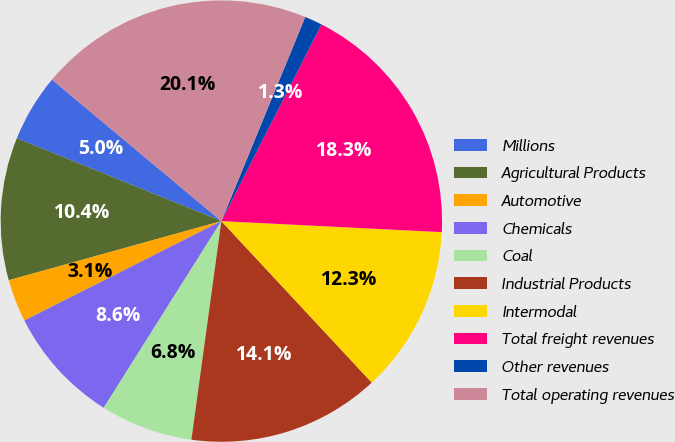<chart> <loc_0><loc_0><loc_500><loc_500><pie_chart><fcel>Millions<fcel>Agricultural Products<fcel>Automotive<fcel>Chemicals<fcel>Coal<fcel>Industrial Products<fcel>Intermodal<fcel>Total freight revenues<fcel>Other revenues<fcel>Total operating revenues<nl><fcel>4.95%<fcel>10.44%<fcel>3.12%<fcel>8.61%<fcel>6.78%<fcel>14.1%<fcel>12.27%<fcel>18.3%<fcel>1.29%<fcel>20.13%<nl></chart> 